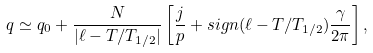<formula> <loc_0><loc_0><loc_500><loc_500>q \simeq q _ { 0 } + \frac { N } { | \ell - T / T _ { 1 / 2 } | } \left [ \frac { j } { p } + s i g n ( \ell - T / T _ { 1 / 2 } ) \frac { \gamma } { 2 \pi } \right ] ,</formula> 